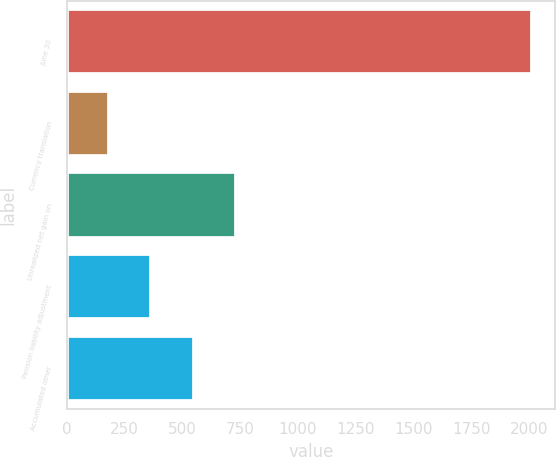Convert chart. <chart><loc_0><loc_0><loc_500><loc_500><bar_chart><fcel>June 30<fcel>Currency translation<fcel>Unrealized net gain on<fcel>Pension liability adjustment<fcel>Accumulated other<nl><fcel>2011<fcel>183.1<fcel>731.47<fcel>365.89<fcel>548.68<nl></chart> 